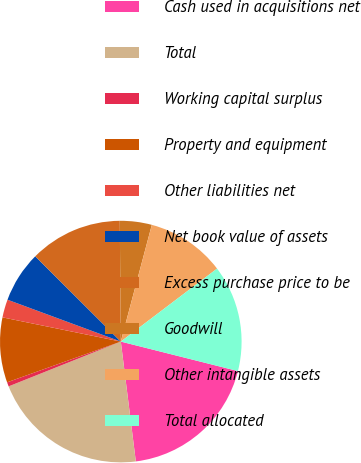<chart> <loc_0><loc_0><loc_500><loc_500><pie_chart><fcel>Cash used in acquisitions net<fcel>Total<fcel>Working capital surplus<fcel>Property and equipment<fcel>Other liabilities net<fcel>Net book value of assets<fcel>Excess purchase price to be<fcel>Goodwill<fcel>Other intangible assets<fcel>Total allocated<nl><fcel>19.09%<fcel>20.94%<fcel>0.57%<fcel>8.69%<fcel>2.42%<fcel>6.84%<fcel>12.39%<fcel>4.27%<fcel>10.54%<fcel>14.25%<nl></chart> 